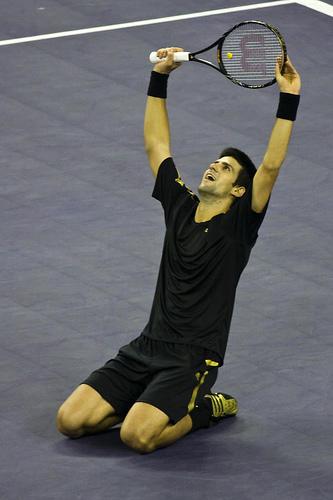What sport are they playing?
Be succinct. Tennis. What brand racket is he using?
Short answer required. Wilson. Does his hair match his clothing color?
Concise answer only. Yes. 